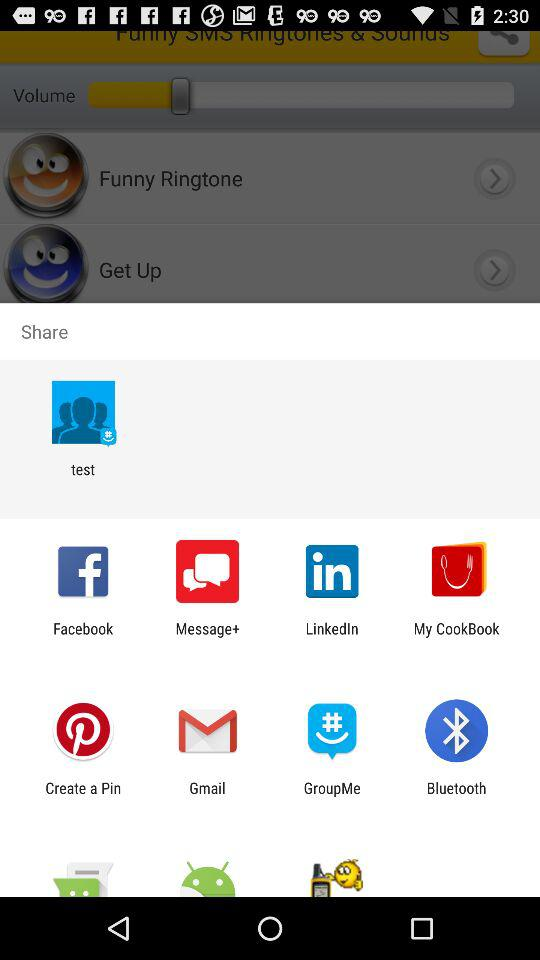What are the different sharing options?
Answer the question using a single word or phrase. The different sharing options are "test", "Facebook", "Message+", "LinkedIn", "My CookBook", "Create a Pin", "Gmail", "GroupMe" and "Bluetooth" 